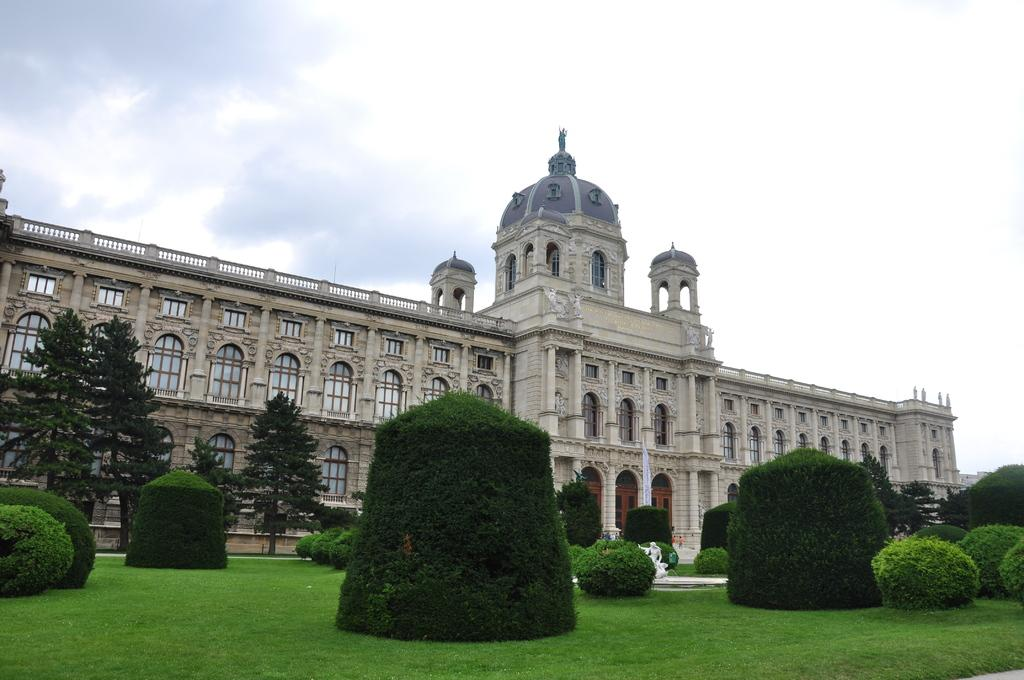What type of structure is present in the image? There is a building in the image. What is the ground covered with in the image? There is green grass on the ground. What type of vegetation can be seen in the image? There are plants and trees in the image. What is visible at the top of the image? The sky is visible at the top of the image. Can you see a boat in the image? No, there is no boat present in the image. What type of view can be seen from the building in the image? The image does not provide a view from the building, as it only shows the exterior of the structure. 